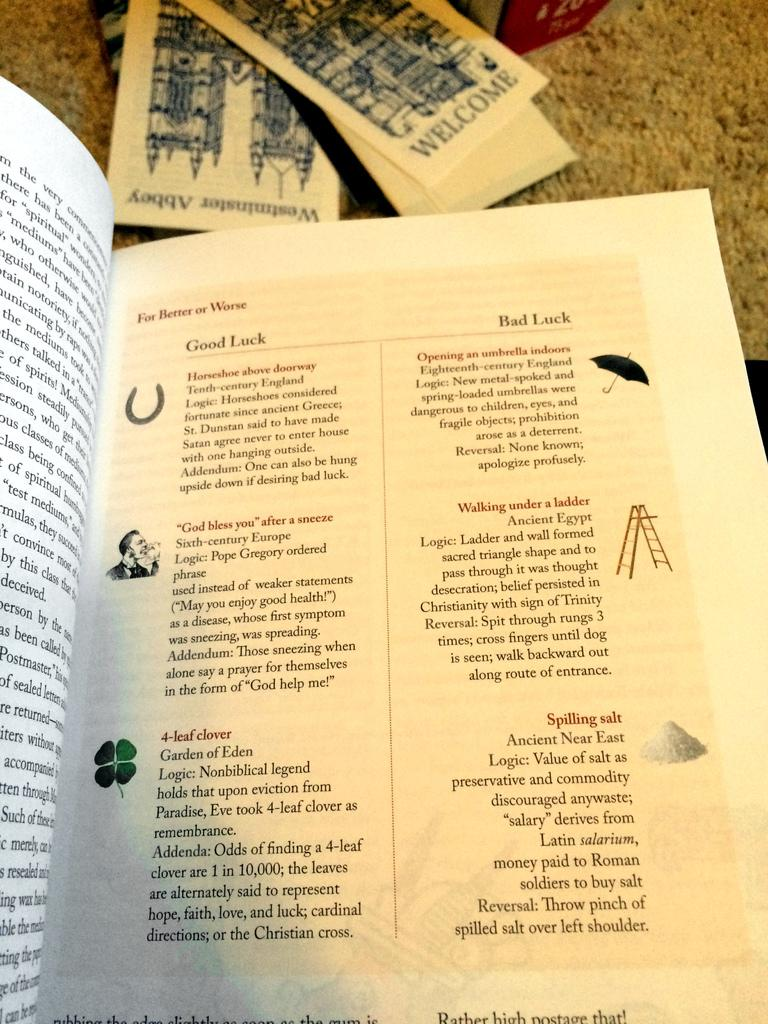<image>
Provide a brief description of the given image. a page that says 'good luck' and 'bad luck' on it 